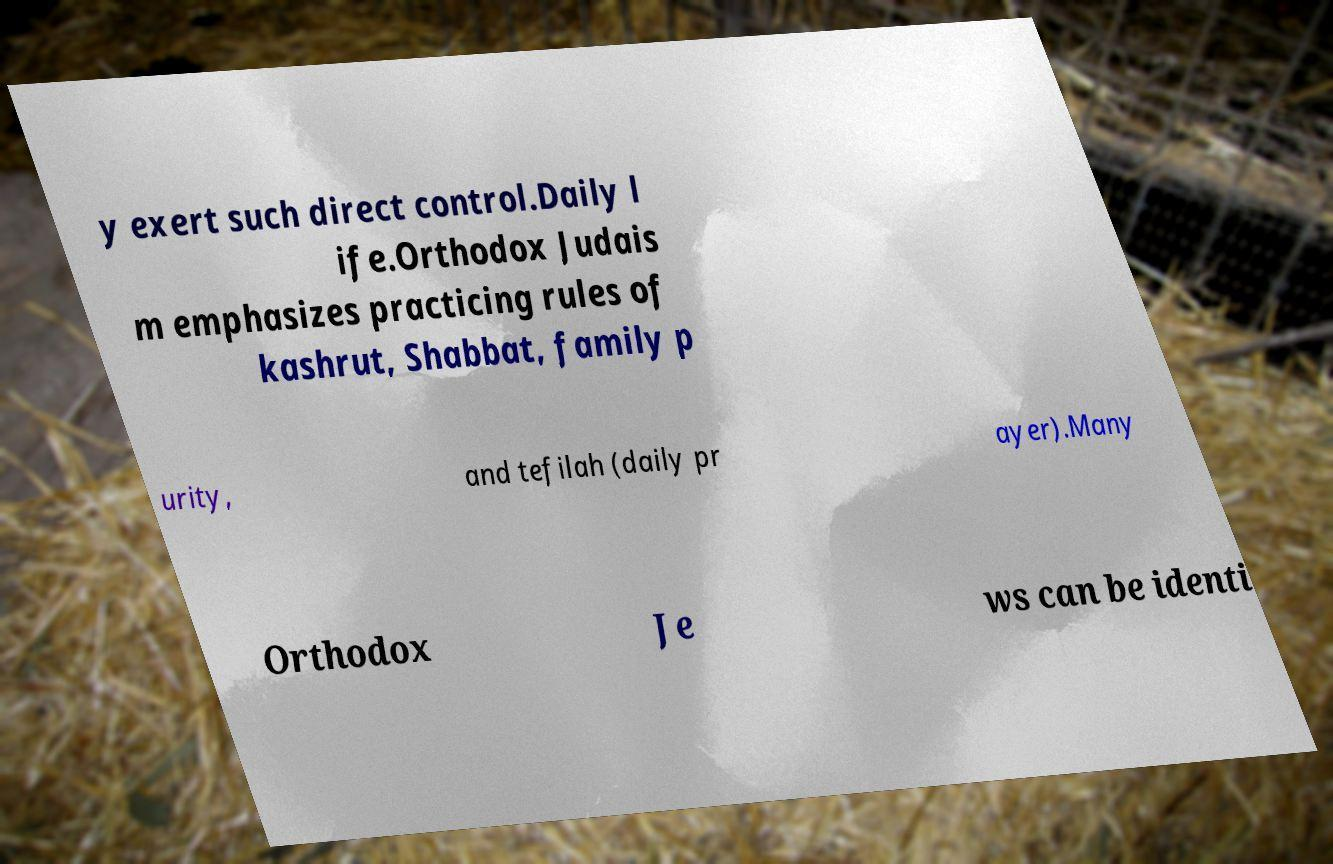I need the written content from this picture converted into text. Can you do that? y exert such direct control.Daily l ife.Orthodox Judais m emphasizes practicing rules of kashrut, Shabbat, family p urity, and tefilah (daily pr ayer).Many Orthodox Je ws can be identi 